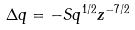Convert formula to latex. <formula><loc_0><loc_0><loc_500><loc_500>\Delta q = - S q ^ { 1 / 2 } z ^ { - 7 / 2 }</formula> 